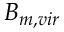<formula> <loc_0><loc_0><loc_500><loc_500>B _ { m , v i r }</formula> 